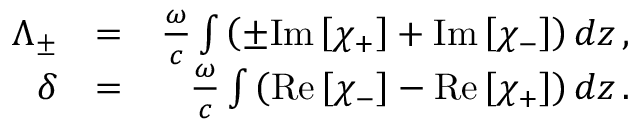<formula> <loc_0><loc_0><loc_500><loc_500>\begin{array} { r l r } { \Lambda _ { \pm } } & { = } & { \frac { \omega } { c } \int \left ( \pm I m \left [ \chi _ { + } \right ] + I m \left [ \chi _ { - } \right ] \right ) d z \, , } \\ { \delta } & { = } & { \frac { \omega } { c } \int \left ( R e \left [ \chi _ { - } \right ] - R e \left [ \chi _ { + } \right ] \right ) d z \, . } \end{array}</formula> 